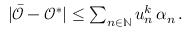Convert formula to latex. <formula><loc_0><loc_0><loc_500><loc_500>\begin{array} { r } { | \bar { \mathcal { O } } - \mathcal { O } ^ { * } | \leq \sum _ { n \in \mathbb { N } } u _ { n } ^ { k } \, \alpha _ { n } \, . } \end{array}</formula> 